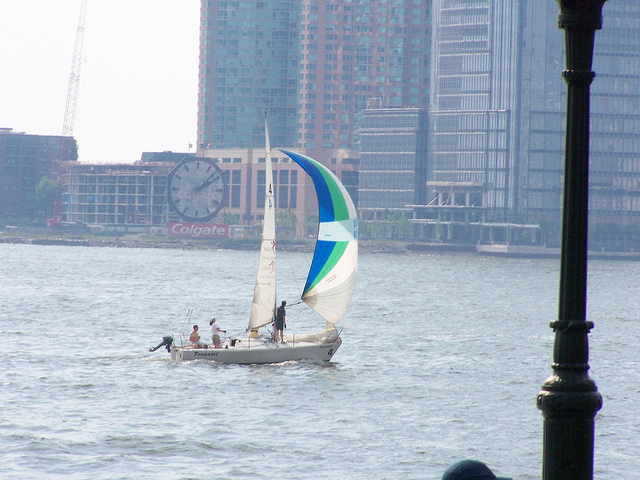What period of the day is shown here?
A. morning
B. afternoon
C. evening
D. night The image depicts a scene that suggests it is the afternoon. Based on the brightness and the quality of light, which implies the sun is likely still high in the sky, but not at its zenith as it would be around noon. The shadows are present but not elongated as they would be in the early morning or late afternoon, further supporting the conclusion that option B (afternoon) is the most accurate. 